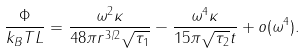<formula> <loc_0><loc_0><loc_500><loc_500>\frac { \Phi } { k _ { B } T L } = \frac { \omega ^ { 2 } \kappa } { 4 8 \pi r ^ { 3 / 2 } \sqrt { \tau _ { 1 } } } - \frac { \omega ^ { 4 } \kappa } { 1 5 \pi \sqrt { \tau _ { 2 } } t } + o ( \omega ^ { 4 } ) .</formula> 